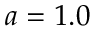<formula> <loc_0><loc_0><loc_500><loc_500>a = 1 . 0</formula> 